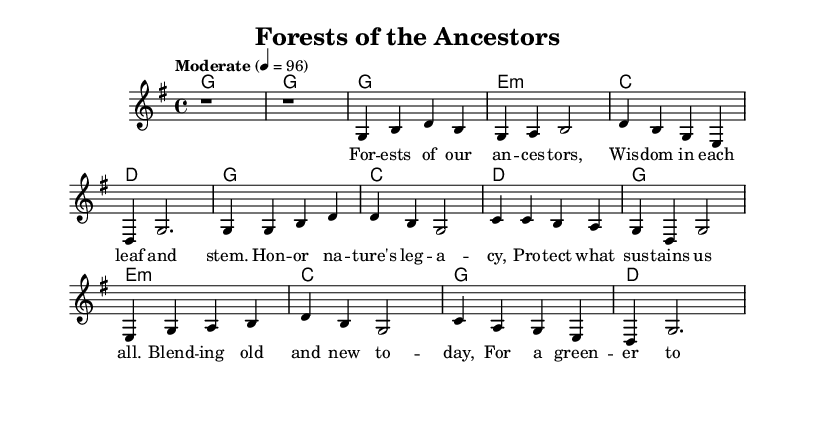What is the key signature of this music? The key signature is G major, which has one sharp (F#). You can identify this by looking at the key signature at the beginning of the staff, which indicates the use of one sharp note, confirming it as G major.
Answer: G major What is the time signature of this piece? The time signature is 4/4, indicated at the beginning of the score. This means there are four beats in a measure, and the quarter note gets one beat.
Answer: 4/4 What is the tempo marking indicated in the score? The tempo marking is "Moderate" with a metronome marking of 4 = 96. This indicates the speed at which the music should be played, suggesting a moderate pace with 96 beats per minute.
Answer: Moderate How many measures are in the chorus section? The chorus consists of four measures, as evident from the music, which shows four lines with musical notation under the chorus lyrics. Each line corresponds to a measure, confirming the total.
Answer: 4 What is the relationship depicted in the bridge lyrics? The bridge lyrics express a blending of old and new for future conservation, highlighting the connection between ancient wisdom and contemporary efforts for sustainability. This reflects a theme of continuity and preservation of nature.
Answer: Blending old and new What is the chord used in the first harmony of the verse? The first chord in the verse is G major, which can be identified from the harmonic notation above the melody in the score, marked clearly at the beginning of the verse.
Answer: G What thematic element does the chorus glorify? The chorus glorifies nature's legacy, emphasizing the importance of protecting what sustains us, as indicated by the lyrics that explicitly mention honoring nature's contributions to human life.
Answer: Nature’s legacy 